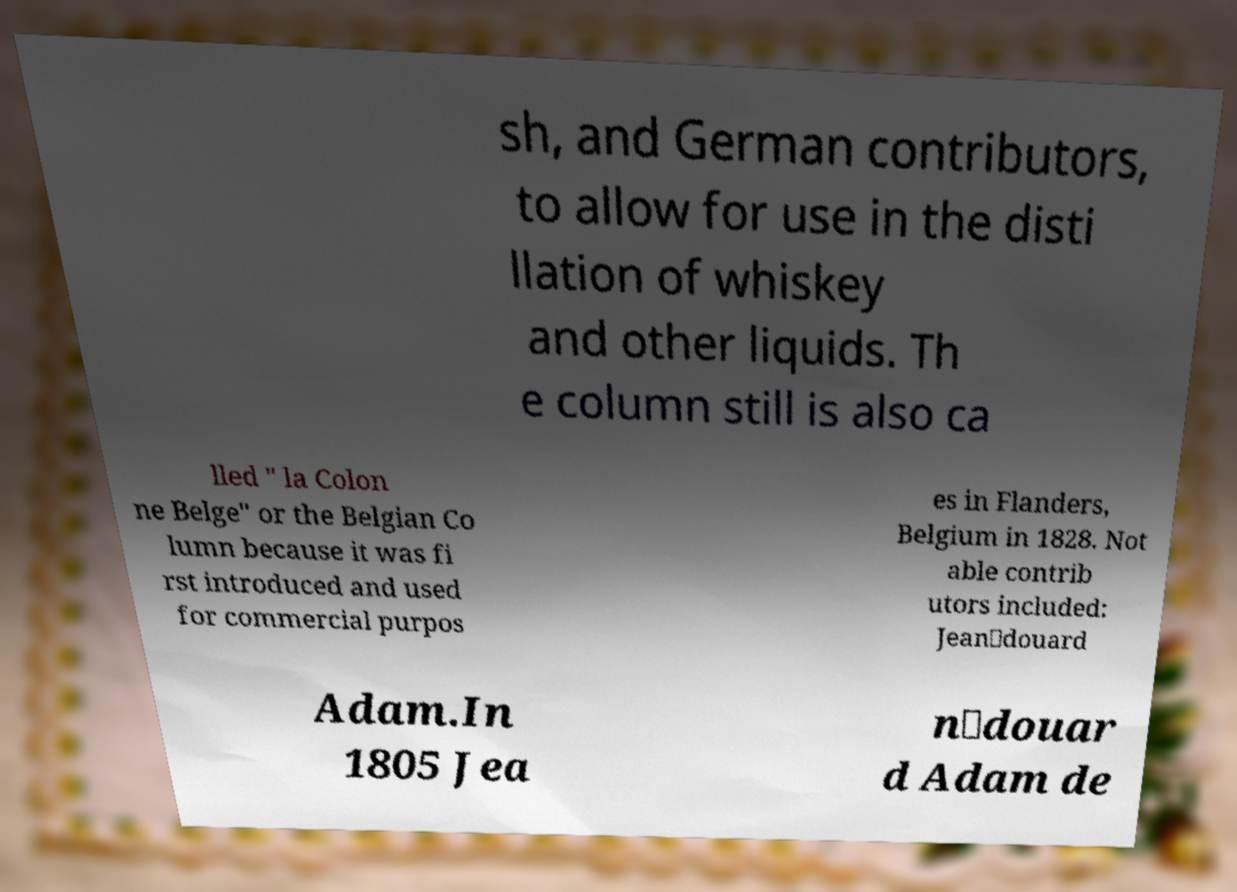Could you extract and type out the text from this image? sh, and German contributors, to allow for use in the disti llation of whiskey and other liquids. Th e column still is also ca lled " la Colon ne Belge" or the Belgian Co lumn because it was fi rst introduced and used for commercial purpos es in Flanders, Belgium in 1828. Not able contrib utors included: Jean‐douard Adam.In 1805 Jea n‐douar d Adam de 